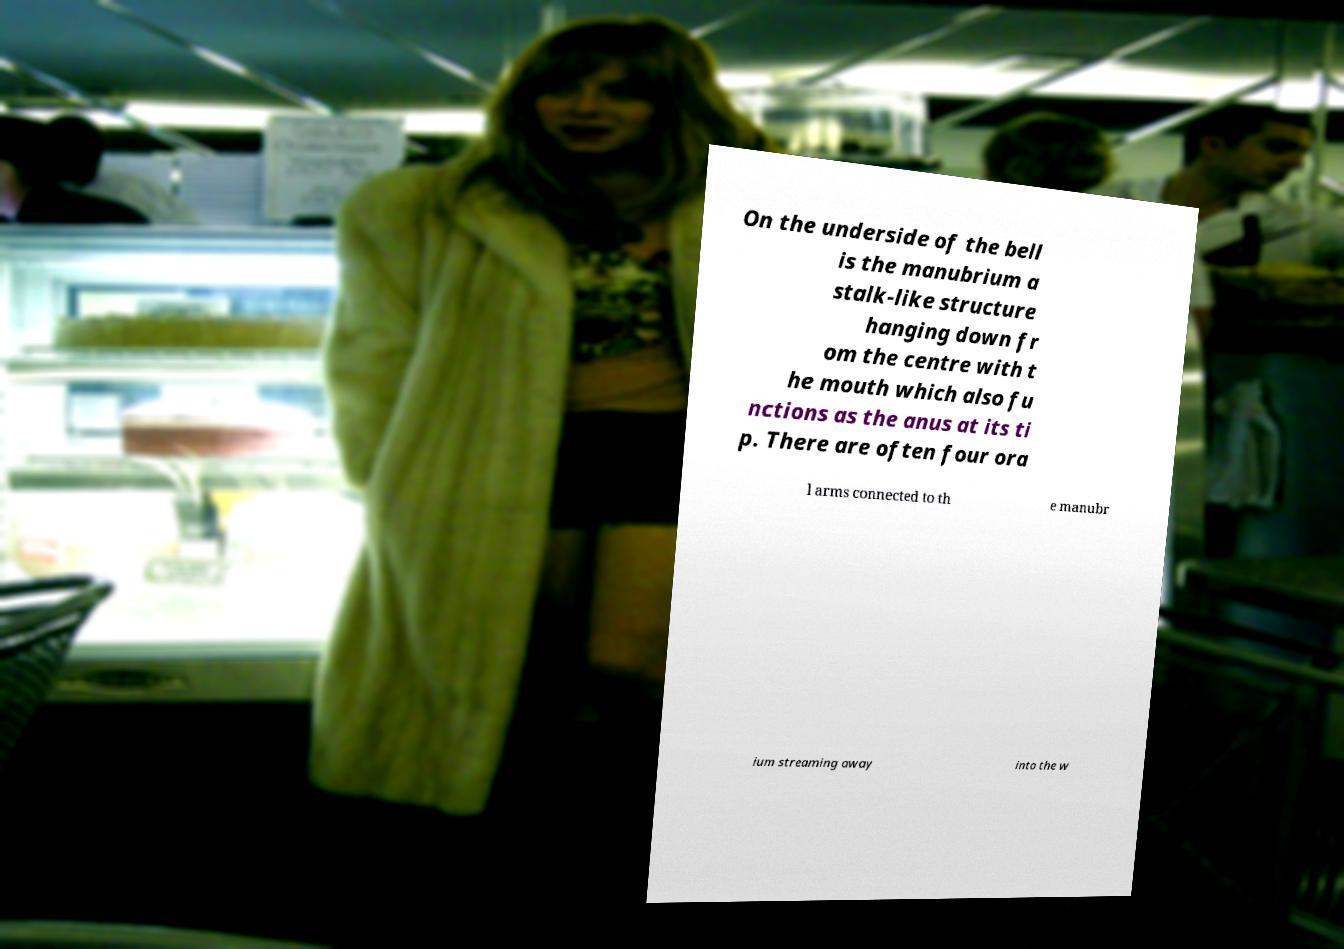Could you assist in decoding the text presented in this image and type it out clearly? On the underside of the bell is the manubrium a stalk-like structure hanging down fr om the centre with t he mouth which also fu nctions as the anus at its ti p. There are often four ora l arms connected to th e manubr ium streaming away into the w 